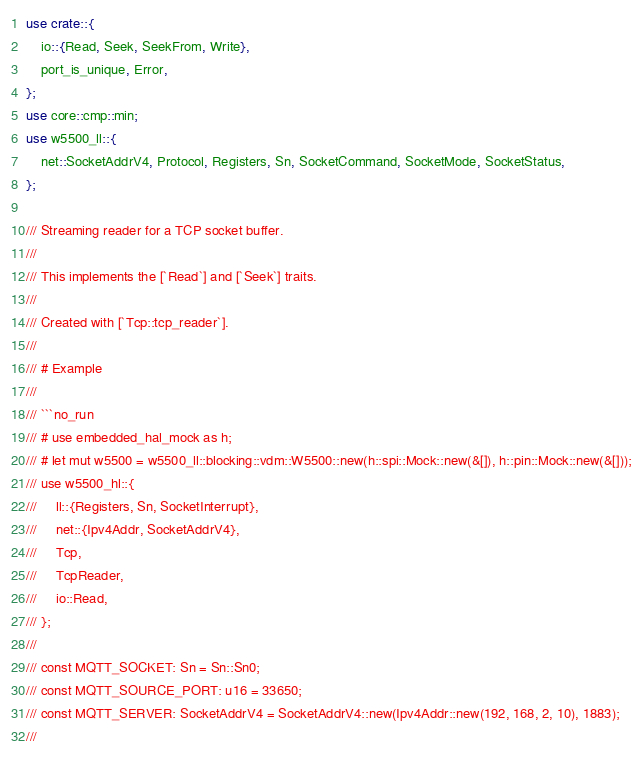<code> <loc_0><loc_0><loc_500><loc_500><_Rust_>use crate::{
    io::{Read, Seek, SeekFrom, Write},
    port_is_unique, Error,
};
use core::cmp::min;
use w5500_ll::{
    net::SocketAddrV4, Protocol, Registers, Sn, SocketCommand, SocketMode, SocketStatus,
};

/// Streaming reader for a TCP socket buffer.
///
/// This implements the [`Read`] and [`Seek`] traits.
///
/// Created with [`Tcp::tcp_reader`].
///
/// # Example
///
/// ```no_run
/// # use embedded_hal_mock as h;
/// # let mut w5500 = w5500_ll::blocking::vdm::W5500::new(h::spi::Mock::new(&[]), h::pin::Mock::new(&[]));
/// use w5500_hl::{
///     ll::{Registers, Sn, SocketInterrupt},
///     net::{Ipv4Addr, SocketAddrV4},
///     Tcp,
///     TcpReader,
///     io::Read,
/// };
///
/// const MQTT_SOCKET: Sn = Sn::Sn0;
/// const MQTT_SOURCE_PORT: u16 = 33650;
/// const MQTT_SERVER: SocketAddrV4 = SocketAddrV4::new(Ipv4Addr::new(192, 168, 2, 10), 1883);
///</code> 